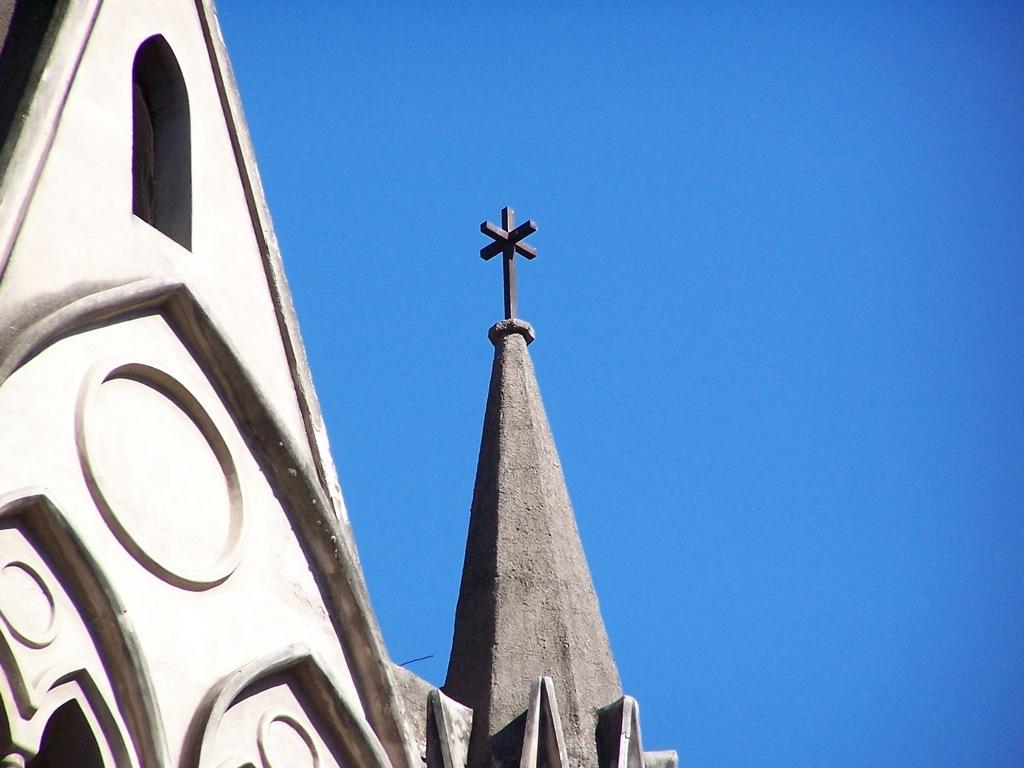What is the main subject in the foreground of the image? There is a building in the foreground of the image. What can be seen in the background of the image? Sky is visible in the background of the image. What is the rate of pizza consumption in the image? There is no information about pizza consumption in the image, as it only features a building and sky. 